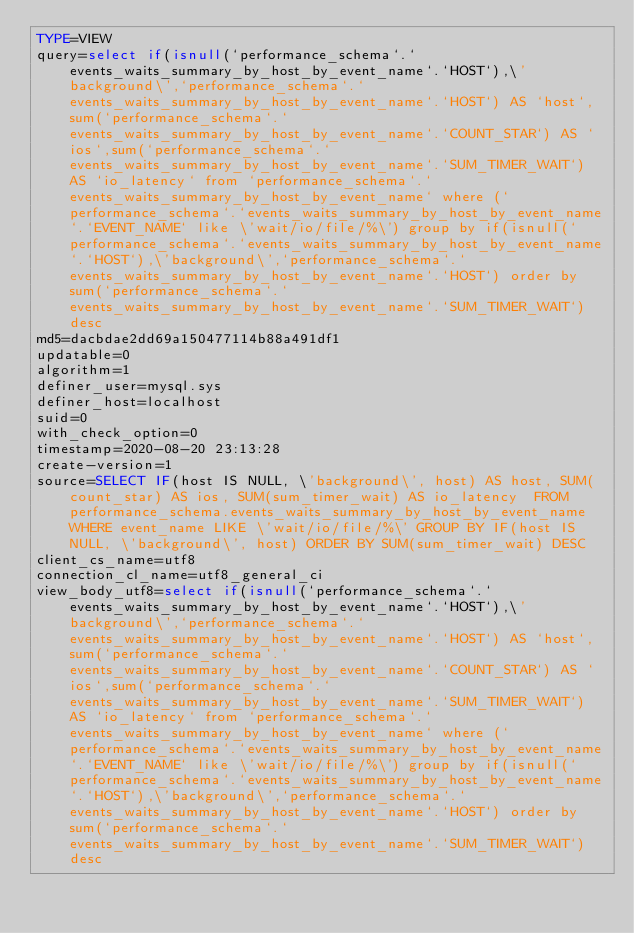<code> <loc_0><loc_0><loc_500><loc_500><_VisualBasic_>TYPE=VIEW
query=select if(isnull(`performance_schema`.`events_waits_summary_by_host_by_event_name`.`HOST`),\'background\',`performance_schema`.`events_waits_summary_by_host_by_event_name`.`HOST`) AS `host`,sum(`performance_schema`.`events_waits_summary_by_host_by_event_name`.`COUNT_STAR`) AS `ios`,sum(`performance_schema`.`events_waits_summary_by_host_by_event_name`.`SUM_TIMER_WAIT`) AS `io_latency` from `performance_schema`.`events_waits_summary_by_host_by_event_name` where (`performance_schema`.`events_waits_summary_by_host_by_event_name`.`EVENT_NAME` like \'wait/io/file/%\') group by if(isnull(`performance_schema`.`events_waits_summary_by_host_by_event_name`.`HOST`),\'background\',`performance_schema`.`events_waits_summary_by_host_by_event_name`.`HOST`) order by sum(`performance_schema`.`events_waits_summary_by_host_by_event_name`.`SUM_TIMER_WAIT`) desc
md5=dacbdae2dd69a150477114b88a491df1
updatable=0
algorithm=1
definer_user=mysql.sys
definer_host=localhost
suid=0
with_check_option=0
timestamp=2020-08-20 23:13:28
create-version=1
source=SELECT IF(host IS NULL, \'background\', host) AS host, SUM(count_star) AS ios, SUM(sum_timer_wait) AS io_latency  FROM performance_schema.events_waits_summary_by_host_by_event_name WHERE event_name LIKE \'wait/io/file/%\' GROUP BY IF(host IS NULL, \'background\', host) ORDER BY SUM(sum_timer_wait) DESC
client_cs_name=utf8
connection_cl_name=utf8_general_ci
view_body_utf8=select if(isnull(`performance_schema`.`events_waits_summary_by_host_by_event_name`.`HOST`),\'background\',`performance_schema`.`events_waits_summary_by_host_by_event_name`.`HOST`) AS `host`,sum(`performance_schema`.`events_waits_summary_by_host_by_event_name`.`COUNT_STAR`) AS `ios`,sum(`performance_schema`.`events_waits_summary_by_host_by_event_name`.`SUM_TIMER_WAIT`) AS `io_latency` from `performance_schema`.`events_waits_summary_by_host_by_event_name` where (`performance_schema`.`events_waits_summary_by_host_by_event_name`.`EVENT_NAME` like \'wait/io/file/%\') group by if(isnull(`performance_schema`.`events_waits_summary_by_host_by_event_name`.`HOST`),\'background\',`performance_schema`.`events_waits_summary_by_host_by_event_name`.`HOST`) order by sum(`performance_schema`.`events_waits_summary_by_host_by_event_name`.`SUM_TIMER_WAIT`) desc
</code> 